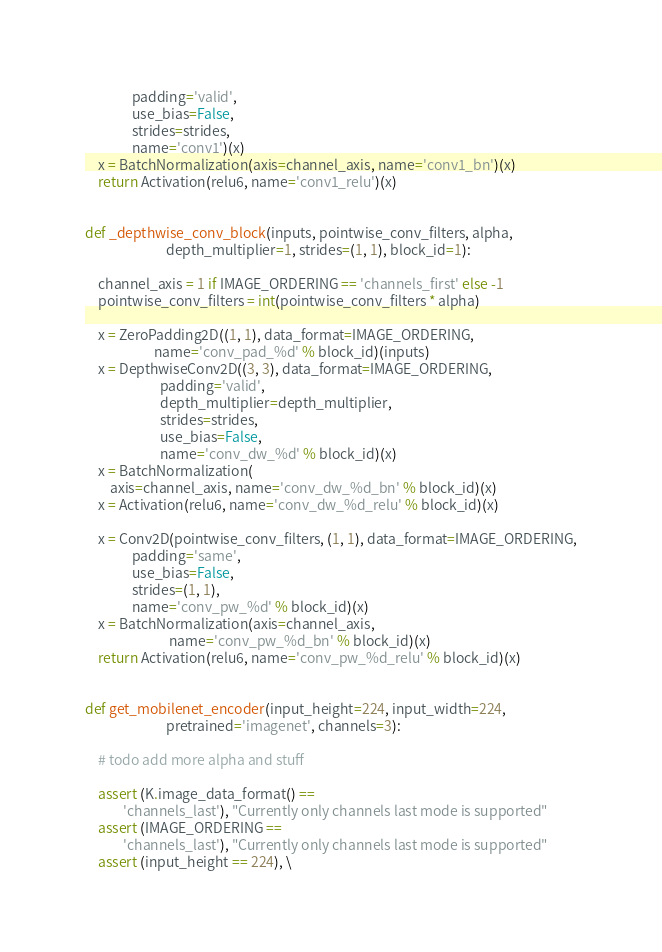<code> <loc_0><loc_0><loc_500><loc_500><_Python_>               padding='valid',
               use_bias=False,
               strides=strides,
               name='conv1')(x)
    x = BatchNormalization(axis=channel_axis, name='conv1_bn')(x)
    return Activation(relu6, name='conv1_relu')(x)


def _depthwise_conv_block(inputs, pointwise_conv_filters, alpha,
                          depth_multiplier=1, strides=(1, 1), block_id=1):

    channel_axis = 1 if IMAGE_ORDERING == 'channels_first' else -1
    pointwise_conv_filters = int(pointwise_conv_filters * alpha)

    x = ZeroPadding2D((1, 1), data_format=IMAGE_ORDERING,
                      name='conv_pad_%d' % block_id)(inputs)
    x = DepthwiseConv2D((3, 3), data_format=IMAGE_ORDERING,
                        padding='valid',
                        depth_multiplier=depth_multiplier,
                        strides=strides,
                        use_bias=False,
                        name='conv_dw_%d' % block_id)(x)
    x = BatchNormalization(
        axis=channel_axis, name='conv_dw_%d_bn' % block_id)(x)
    x = Activation(relu6, name='conv_dw_%d_relu' % block_id)(x)

    x = Conv2D(pointwise_conv_filters, (1, 1), data_format=IMAGE_ORDERING,
               padding='same',
               use_bias=False,
               strides=(1, 1),
               name='conv_pw_%d' % block_id)(x)
    x = BatchNormalization(axis=channel_axis,
                           name='conv_pw_%d_bn' % block_id)(x)
    return Activation(relu6, name='conv_pw_%d_relu' % block_id)(x)


def get_mobilenet_encoder(input_height=224, input_width=224,
                          pretrained='imagenet', channels=3):

    # todo add more alpha and stuff

    assert (K.image_data_format() ==
            'channels_last'), "Currently only channels last mode is supported"
    assert (IMAGE_ORDERING ==
            'channels_last'), "Currently only channels last mode is supported"
    assert (input_height == 224), \</code> 